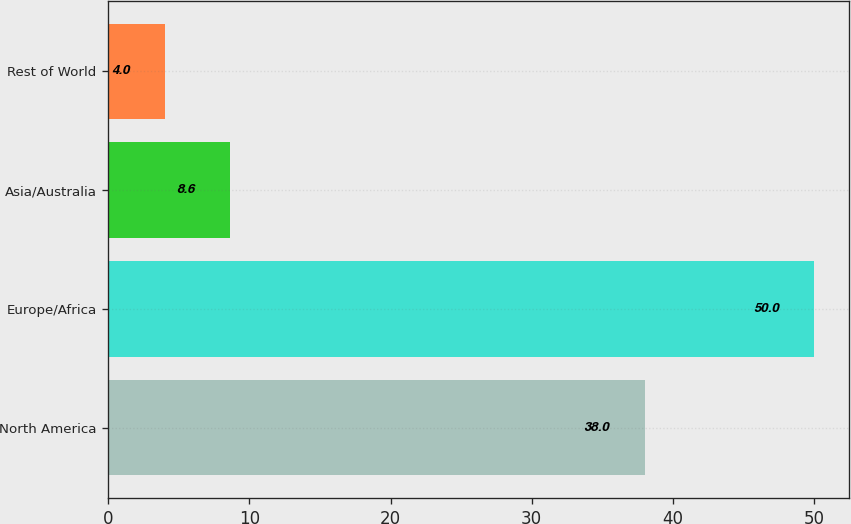Convert chart to OTSL. <chart><loc_0><loc_0><loc_500><loc_500><bar_chart><fcel>North America<fcel>Europe/Africa<fcel>Asia/Australia<fcel>Rest of World<nl><fcel>38<fcel>50<fcel>8.6<fcel>4<nl></chart> 